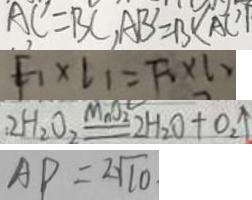<formula> <loc_0><loc_0><loc_500><loc_500>A C = B C , A B = B C A C ^ { \prime } 
 F _ { 1 } \times l _ { 1 } = F _ { 1 } \times l _ { 2 } 
 : 2 H _ { 2 } O _ { 2 } \xlongequal { M n O _ { 2 } } 2 H _ { 2 } O + O _ { 2 } \uparrow 
 A P = 2 \sqrt { 1 0 }</formula> 